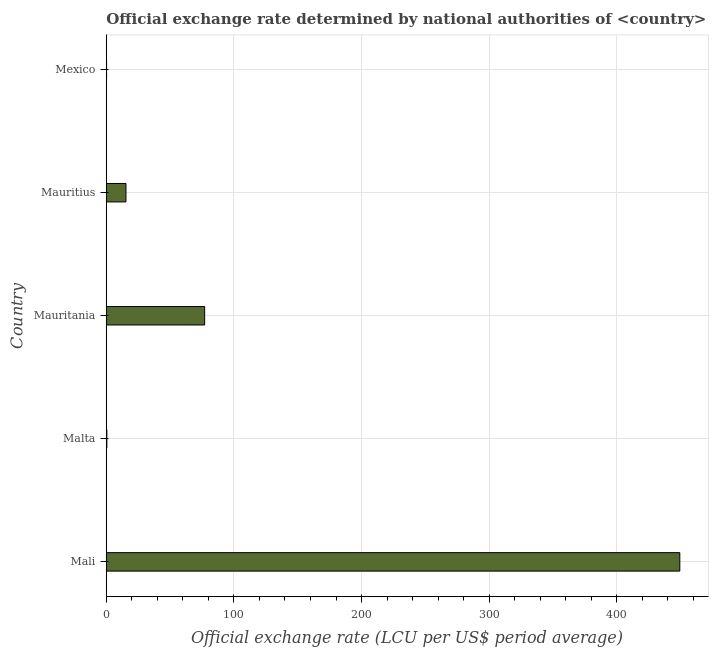Does the graph contain any zero values?
Make the answer very short. No. What is the title of the graph?
Provide a succinct answer. Official exchange rate determined by national authorities of <country>. What is the label or title of the X-axis?
Offer a terse response. Official exchange rate (LCU per US$ period average). What is the label or title of the Y-axis?
Provide a succinct answer. Country. What is the official exchange rate in Mexico?
Provide a succinct answer. 0.26. Across all countries, what is the maximum official exchange rate?
Your answer should be compact. 449.26. Across all countries, what is the minimum official exchange rate?
Provide a succinct answer. 0.26. In which country was the official exchange rate maximum?
Offer a terse response. Mali. In which country was the official exchange rate minimum?
Provide a short and direct response. Mexico. What is the sum of the official exchange rate?
Offer a very short reply. 542.52. What is the difference between the official exchange rate in Malta and Mexico?
Your answer should be very brief. 0.21. What is the average official exchange rate per country?
Offer a very short reply. 108.5. What is the median official exchange rate?
Make the answer very short. 15.44. In how many countries, is the official exchange rate greater than 100 ?
Provide a succinct answer. 1. What is the ratio of the official exchange rate in Mali to that in Mexico?
Provide a short and direct response. 1748.98. Is the difference between the official exchange rate in Mauritania and Mauritius greater than the difference between any two countries?
Your answer should be compact. No. What is the difference between the highest and the second highest official exchange rate?
Make the answer very short. 372.18. What is the difference between the highest and the lowest official exchange rate?
Your response must be concise. 449.01. In how many countries, is the official exchange rate greater than the average official exchange rate taken over all countries?
Offer a terse response. 1. Are all the bars in the graph horizontal?
Ensure brevity in your answer.  Yes. How many countries are there in the graph?
Provide a succinct answer. 5. What is the difference between two consecutive major ticks on the X-axis?
Make the answer very short. 100. Are the values on the major ticks of X-axis written in scientific E-notation?
Your response must be concise. No. What is the Official exchange rate (LCU per US$ period average) in Mali?
Provide a short and direct response. 449.26. What is the Official exchange rate (LCU per US$ period average) of Malta?
Provide a succinct answer. 0.47. What is the Official exchange rate (LCU per US$ period average) in Mauritania?
Make the answer very short. 77.08. What is the Official exchange rate (LCU per US$ period average) in Mauritius?
Your answer should be very brief. 15.44. What is the Official exchange rate (LCU per US$ period average) of Mexico?
Provide a succinct answer. 0.26. What is the difference between the Official exchange rate (LCU per US$ period average) in Mali and Malta?
Your answer should be very brief. 448.79. What is the difference between the Official exchange rate (LCU per US$ period average) in Mali and Mauritania?
Your response must be concise. 372.18. What is the difference between the Official exchange rate (LCU per US$ period average) in Mali and Mauritius?
Your answer should be compact. 433.82. What is the difference between the Official exchange rate (LCU per US$ period average) in Mali and Mexico?
Offer a terse response. 449.01. What is the difference between the Official exchange rate (LCU per US$ period average) in Malta and Mauritania?
Ensure brevity in your answer.  -76.62. What is the difference between the Official exchange rate (LCU per US$ period average) in Malta and Mauritius?
Your answer should be very brief. -14.97. What is the difference between the Official exchange rate (LCU per US$ period average) in Malta and Mexico?
Keep it short and to the point. 0.21. What is the difference between the Official exchange rate (LCU per US$ period average) in Mauritania and Mauritius?
Your answer should be very brief. 61.64. What is the difference between the Official exchange rate (LCU per US$ period average) in Mauritania and Mexico?
Your answer should be very brief. 76.83. What is the difference between the Official exchange rate (LCU per US$ period average) in Mauritius and Mexico?
Make the answer very short. 15.19. What is the ratio of the Official exchange rate (LCU per US$ period average) in Mali to that in Malta?
Your answer should be very brief. 957.6. What is the ratio of the Official exchange rate (LCU per US$ period average) in Mali to that in Mauritania?
Provide a succinct answer. 5.83. What is the ratio of the Official exchange rate (LCU per US$ period average) in Mali to that in Mauritius?
Keep it short and to the point. 29.09. What is the ratio of the Official exchange rate (LCU per US$ period average) in Mali to that in Mexico?
Keep it short and to the point. 1748.98. What is the ratio of the Official exchange rate (LCU per US$ period average) in Malta to that in Mauritania?
Make the answer very short. 0.01. What is the ratio of the Official exchange rate (LCU per US$ period average) in Malta to that in Mexico?
Your answer should be very brief. 1.83. What is the ratio of the Official exchange rate (LCU per US$ period average) in Mauritania to that in Mauritius?
Provide a succinct answer. 4.99. What is the ratio of the Official exchange rate (LCU per US$ period average) in Mauritania to that in Mexico?
Offer a terse response. 300.09. What is the ratio of the Official exchange rate (LCU per US$ period average) in Mauritius to that in Mexico?
Offer a terse response. 60.12. 